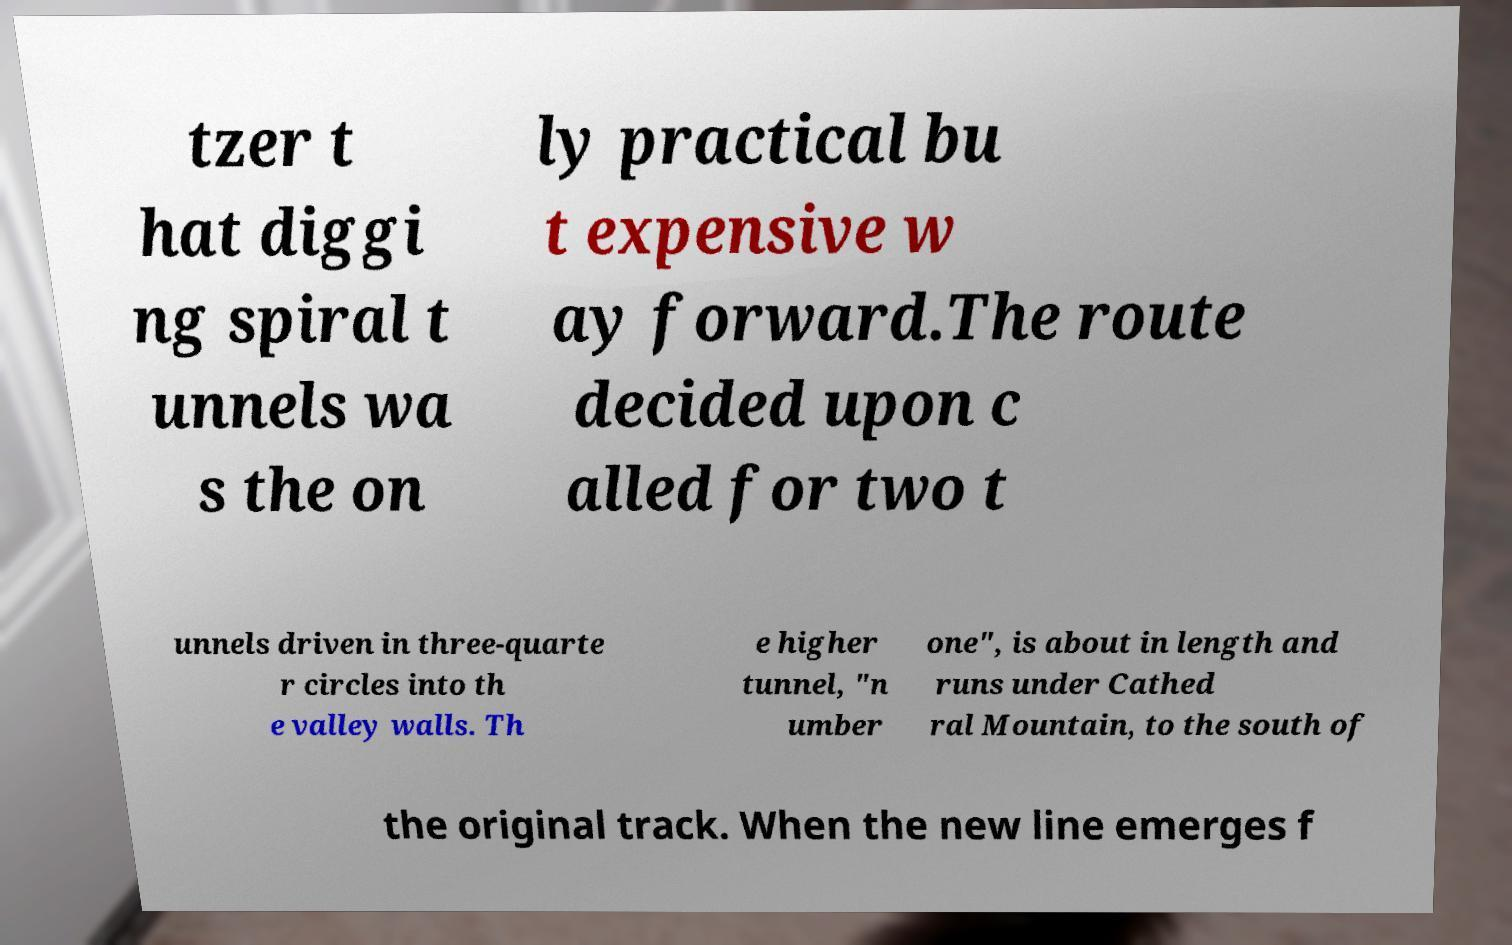There's text embedded in this image that I need extracted. Can you transcribe it verbatim? tzer t hat diggi ng spiral t unnels wa s the on ly practical bu t expensive w ay forward.The route decided upon c alled for two t unnels driven in three-quarte r circles into th e valley walls. Th e higher tunnel, "n umber one", is about in length and runs under Cathed ral Mountain, to the south of the original track. When the new line emerges f 